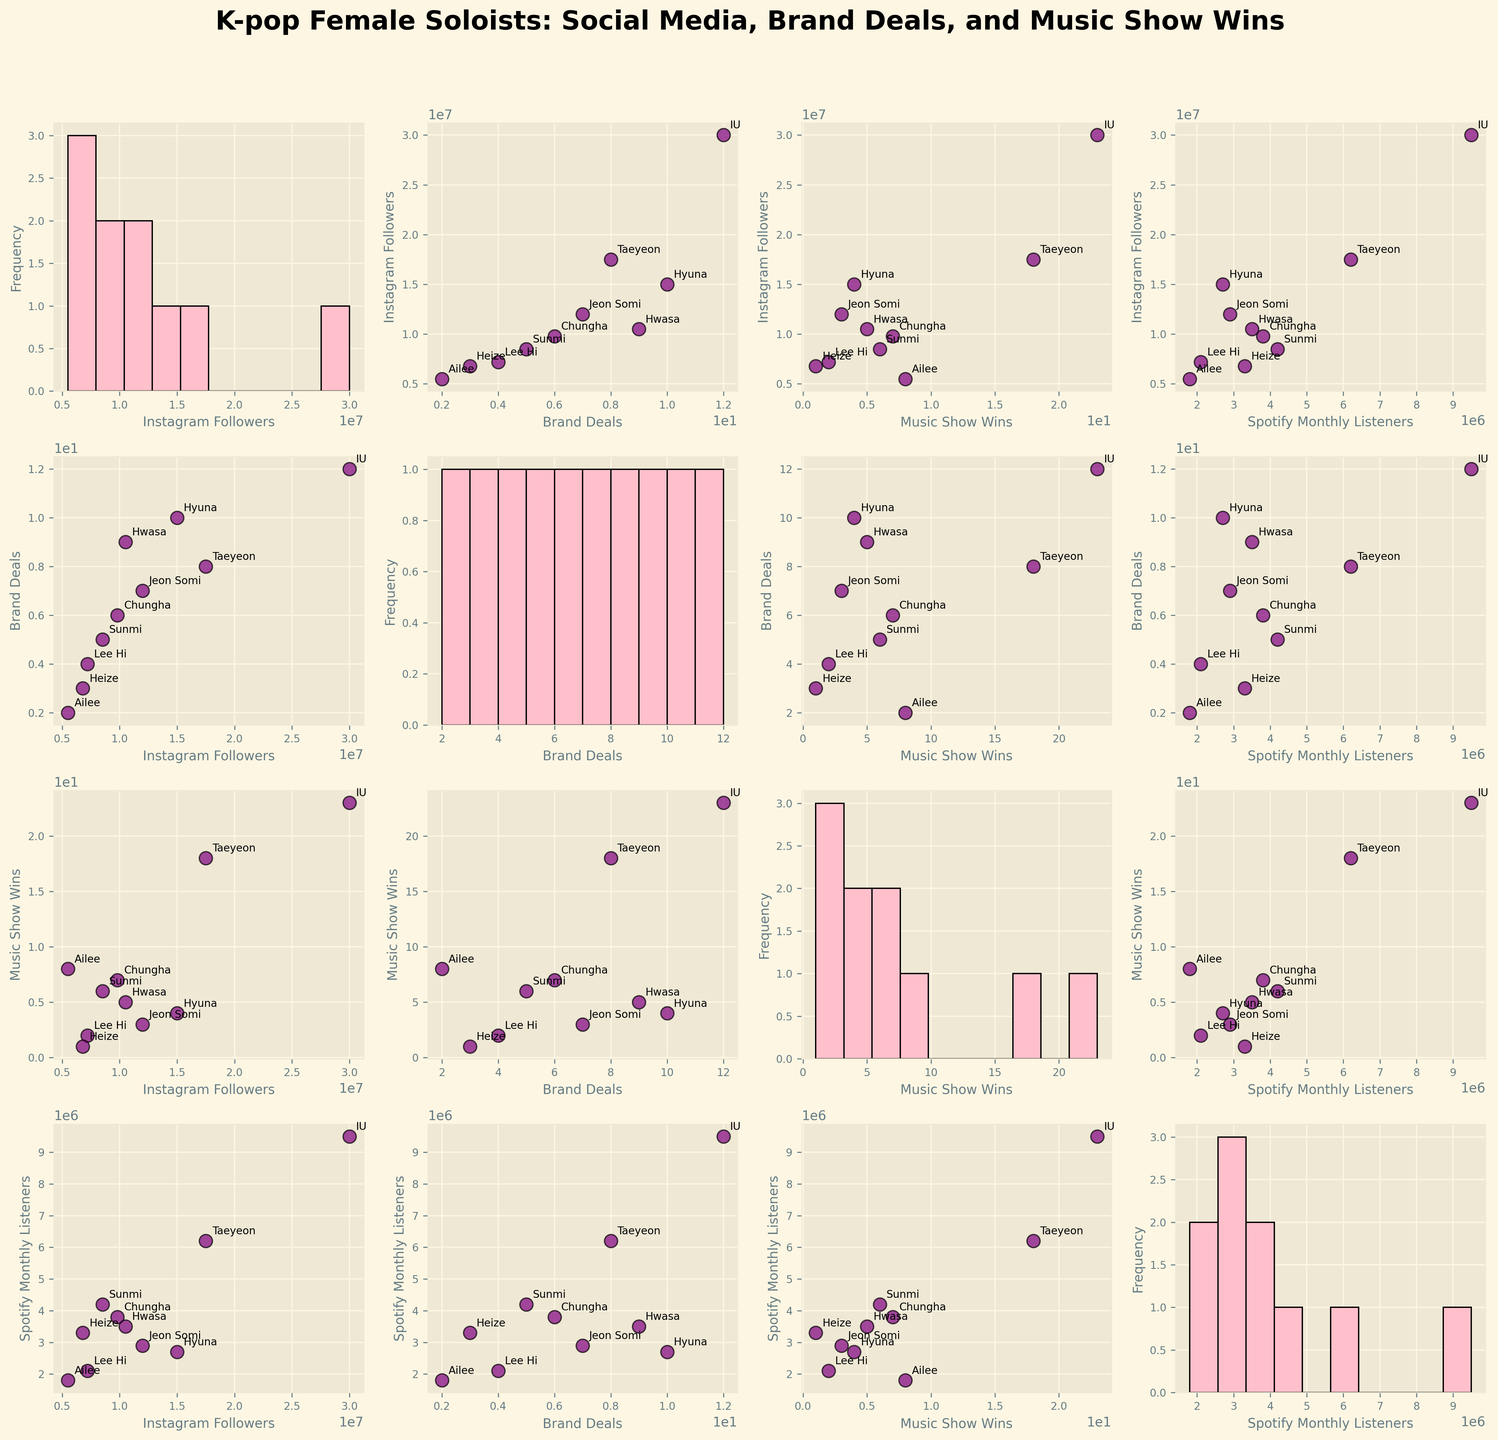What's the title of the figure? The title is usually displayed at the top and provides a summary of the visualized data. From the problem statement, the title is mentioned as "K-pop Female Soloists: Social Media, Brand Deals, and Music Show Wins".
Answer: K-pop Female Soloists: Social Media, Brand Deals, and Music Show Wins What are the axis labels in the scatter plots? Each scatter plot in the figure compares two variables which have axis labels corresponding to the selected pair. The variables include 'Instagram Followers', 'Brand Deals', 'Music Show Wins', and 'Spotify Monthly Listeners', and the labels replace underscores with spaces to make them readable.
Answer: Instagram Followers, Brand Deals, Music Show Wins, Spotify Monthly Listeners Which soloist has the highest number of music show wins and how many wins do they have? By looking at the "Music Show Wins" histogram or scatterplots, you can identify the individual data points. IU is annotated with the highest data point in the "Music Show Wins" axis indicating 23 wins.
Answer: IU with 23 wins What's the average number of brand deals among the soloists? To find the average, sum all the 'Brand Deals' values and divide by the number of soloists, which is 10. (12 + 8 + 6 + 5 + 7 + 9 + 10 + 4 + 3 + 2) = 66; 66 / 10 = 6.6
Answer: 6.6 Which soloist has the fewest Spotify monthly listeners? Check the scatter plots or histograms where the y-axis shows 'Spotify Monthly Listeners'. Ailee has the data point corresponding to 1.8 million listeners, the lowest value.
Answer: Ailee How are Instagram followers related to Spotify monthly listeners for IU? Locate IU's data points in the scatter plots that compare 'Instagram Followers' and 'Spotify Monthly Listeners'. In these plots, IU has 30 million Instagram followers and 9.5 million Spotify monthly listeners.
Answer: 30 million Instagram followers and 9.5 million Spotify monthly listeners Do more brand deals correlate with more music show wins? Review the scatter plot where 'Brand Deals' is on one axis and 'Music Show Wins' is on the other. The distribution of points indicates if there's a visible trend. There appears to be a positive correlation because higher brand deals often align with higher music show wins, e.g., IU and Taeyeon have highest in both metrics.
Answer: Yes What's the difference in Instagram followers between Hyuna and Hwasa? From the scatter plots or annotated points, Hyuna has 15 million followers while Hwasa has 10.5 million. The difference is calculated by subtracting these two values: 15M - 10.5M = 4.5M.
Answer: 4.5 million Compare the relationship of Instagram followers with brand deals for Taeyeon and Hyuna. Observe the scatter plots where 'Instagram Followers' and 'Brand Deals' are compared. Taeyeon has 17.5 million followers and 8 brand deals, while Hyuna has 15 million followers and 10 brand deals. Although Taeyeon has more followers, Hyuna has more brand deals.
Answer: Taeyeon has more followers but fewer brand deals compared to Hyuna 